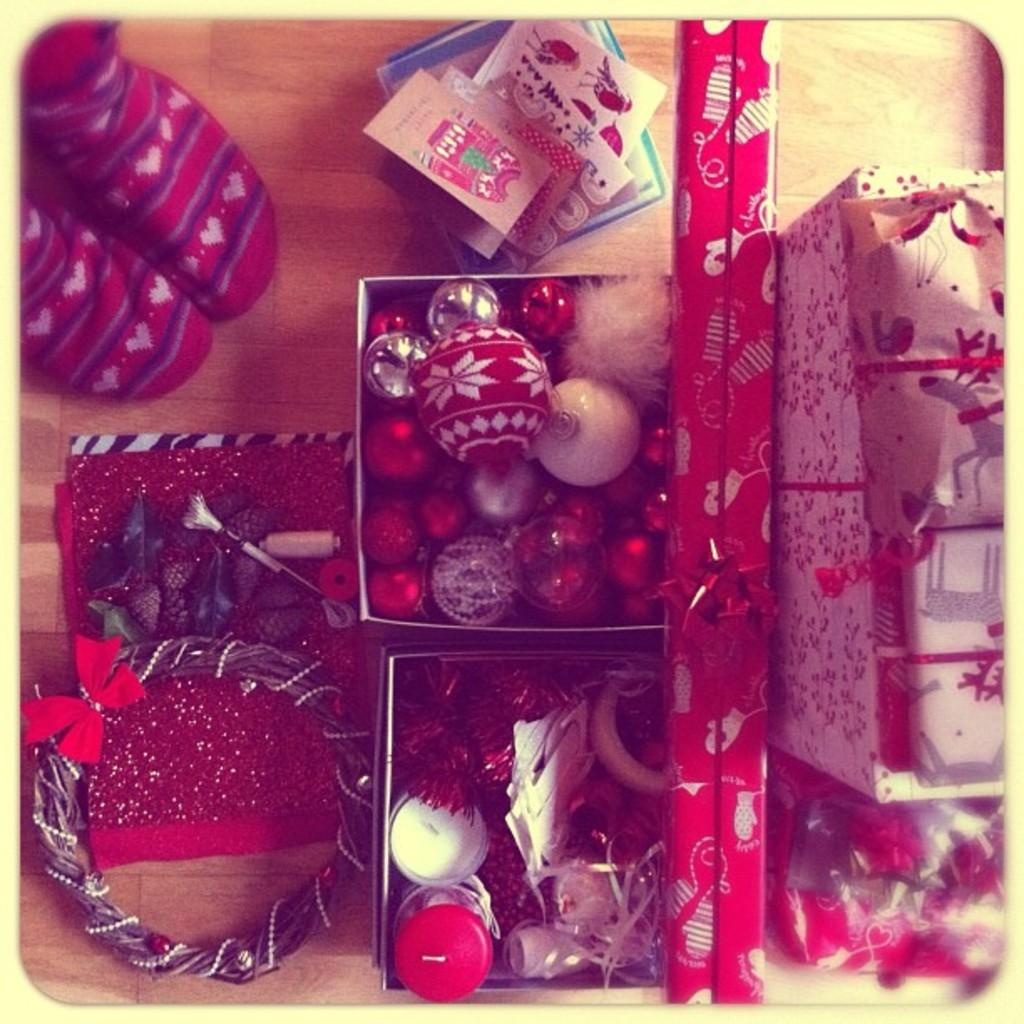What type of objects can be seen in the image? There are boxes, decorative balls, cards, and socks in the image. What is the surface that these objects are placed on? There is a platform in the image. Are the socks hot in the image? The socks are not hot in the image; the fact does not mention any temperature or heat-related information. 